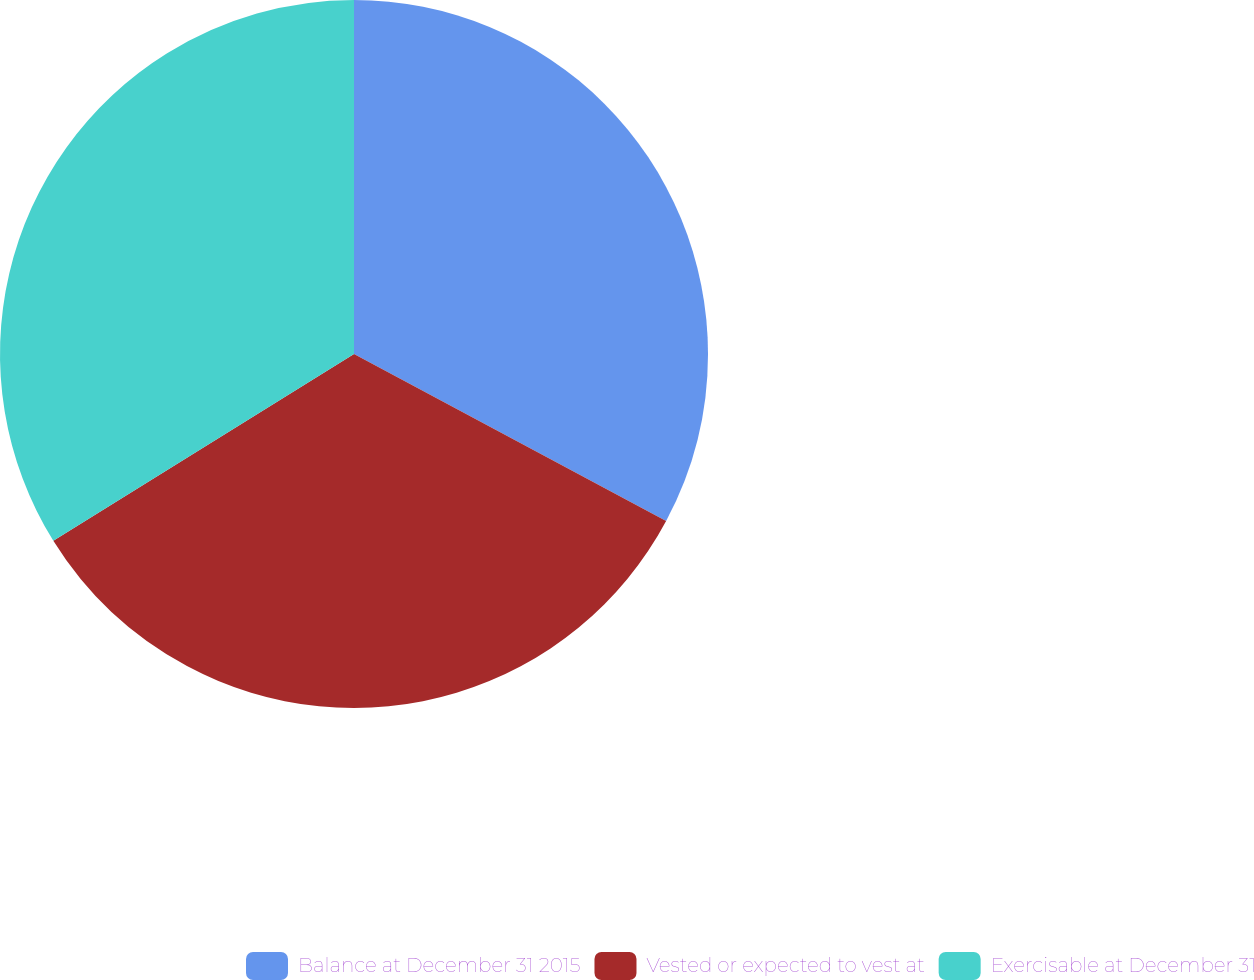Convert chart. <chart><loc_0><loc_0><loc_500><loc_500><pie_chart><fcel>Balance at December 31 2015<fcel>Vested or expected to vest at<fcel>Exercisable at December 31<nl><fcel>32.82%<fcel>33.33%<fcel>33.85%<nl></chart> 